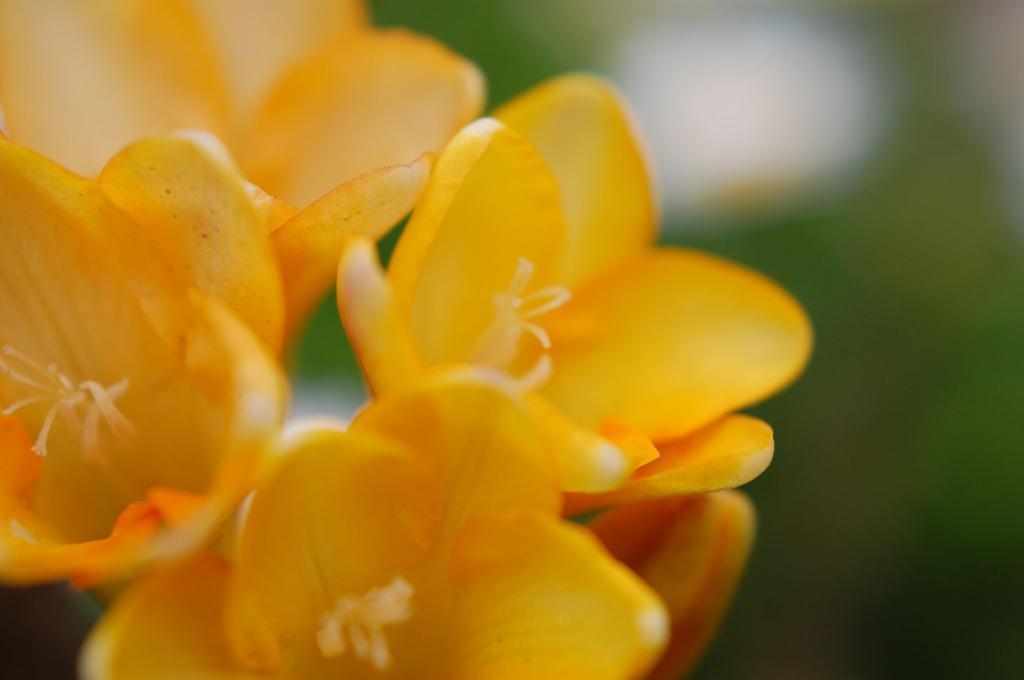Can you describe this image briefly? In this image we can see group of flowers. 